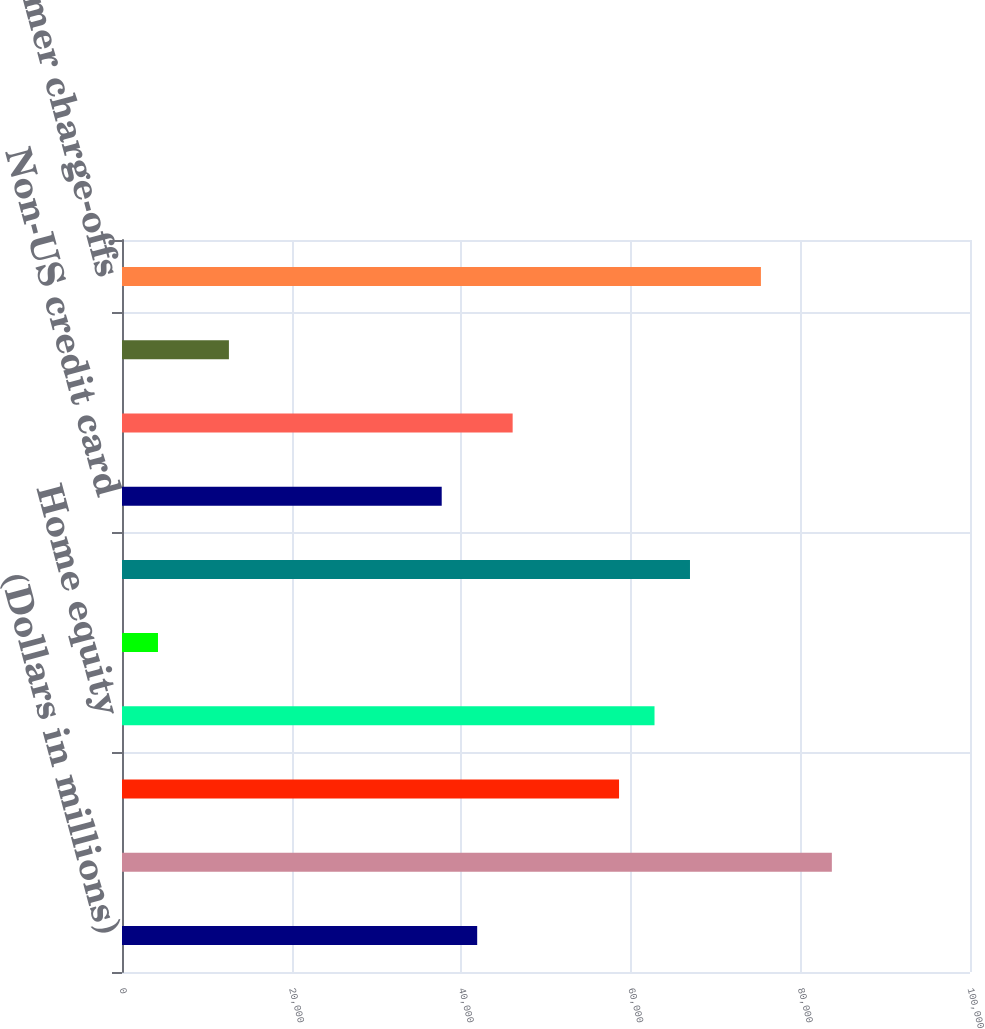<chart> <loc_0><loc_0><loc_500><loc_500><bar_chart><fcel>(Dollars in millions)<fcel>Allowance for loan and lease<fcel>Residential mortgage<fcel>Home equity<fcel>Discontinued real estate<fcel>US credit card<fcel>Non-US credit card<fcel>Direct/Indirect consumer<fcel>Other consumer<fcel>Total consumer charge-offs<nl><fcel>41885<fcel>83709<fcel>58614.6<fcel>62797<fcel>4243.4<fcel>66979.4<fcel>37702.6<fcel>46067.4<fcel>12608.2<fcel>75344.2<nl></chart> 